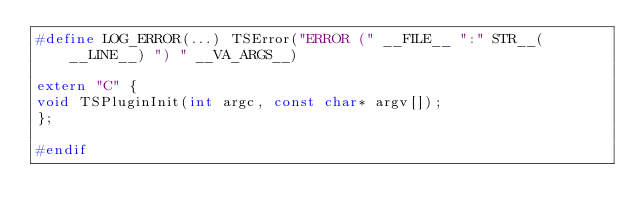<code> <loc_0><loc_0><loc_500><loc_500><_C++_>#define LOG_ERROR(...) TSError("ERROR (" __FILE__ ":" STR__(__LINE__) ") " __VA_ARGS__)

extern "C" {
void TSPluginInit(int argc, const char* argv[]);
};

#endif
</code> 